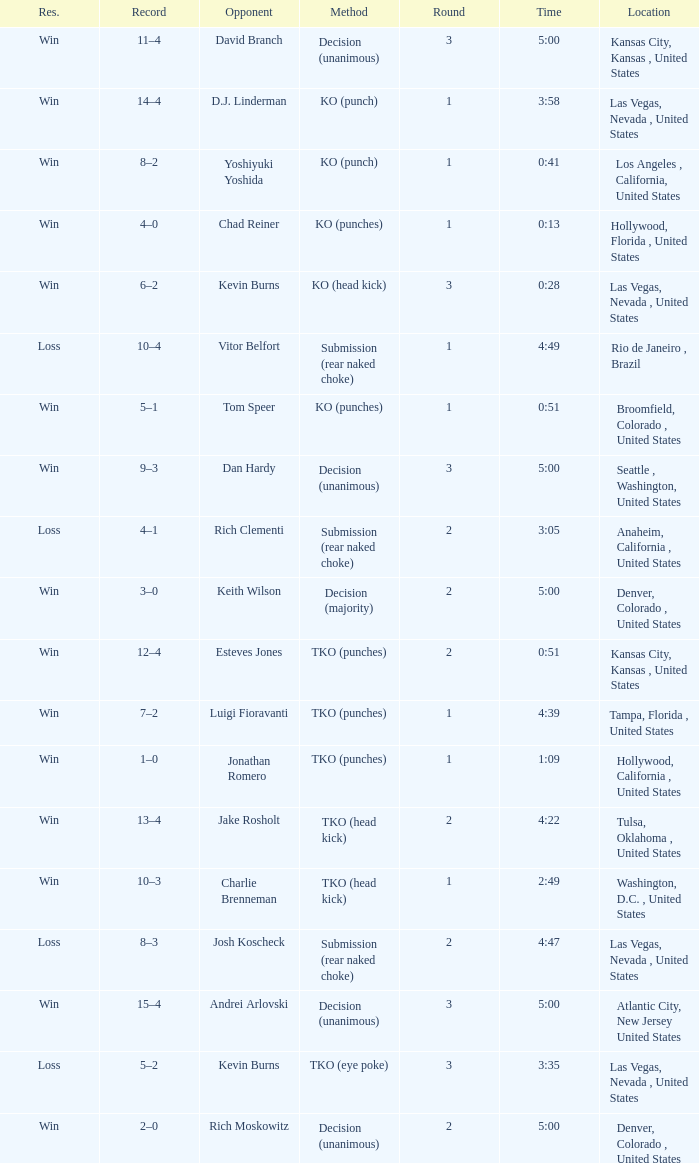What is the result for rounds under 2 against D.J. Linderman? Win. 